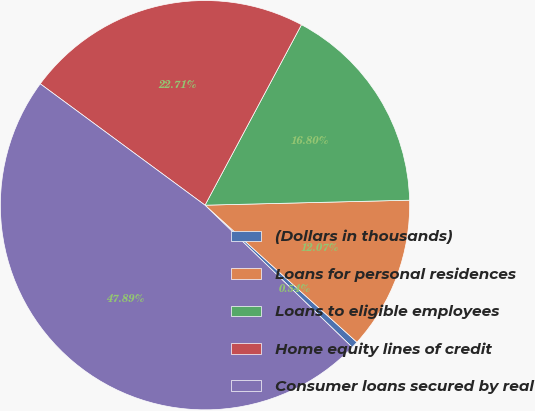Convert chart. <chart><loc_0><loc_0><loc_500><loc_500><pie_chart><fcel>(Dollars in thousands)<fcel>Loans for personal residences<fcel>Loans to eligible employees<fcel>Home equity lines of credit<fcel>Consumer loans secured by real<nl><fcel>0.54%<fcel>12.07%<fcel>16.8%<fcel>22.71%<fcel>47.89%<nl></chart> 